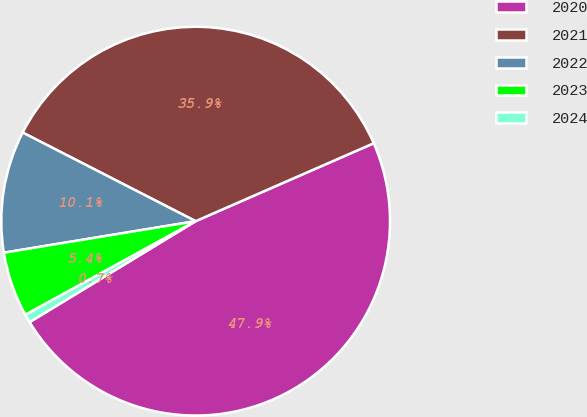Convert chart. <chart><loc_0><loc_0><loc_500><loc_500><pie_chart><fcel>2020<fcel>2021<fcel>2022<fcel>2023<fcel>2024<nl><fcel>47.87%<fcel>35.9%<fcel>10.13%<fcel>5.41%<fcel>0.69%<nl></chart> 